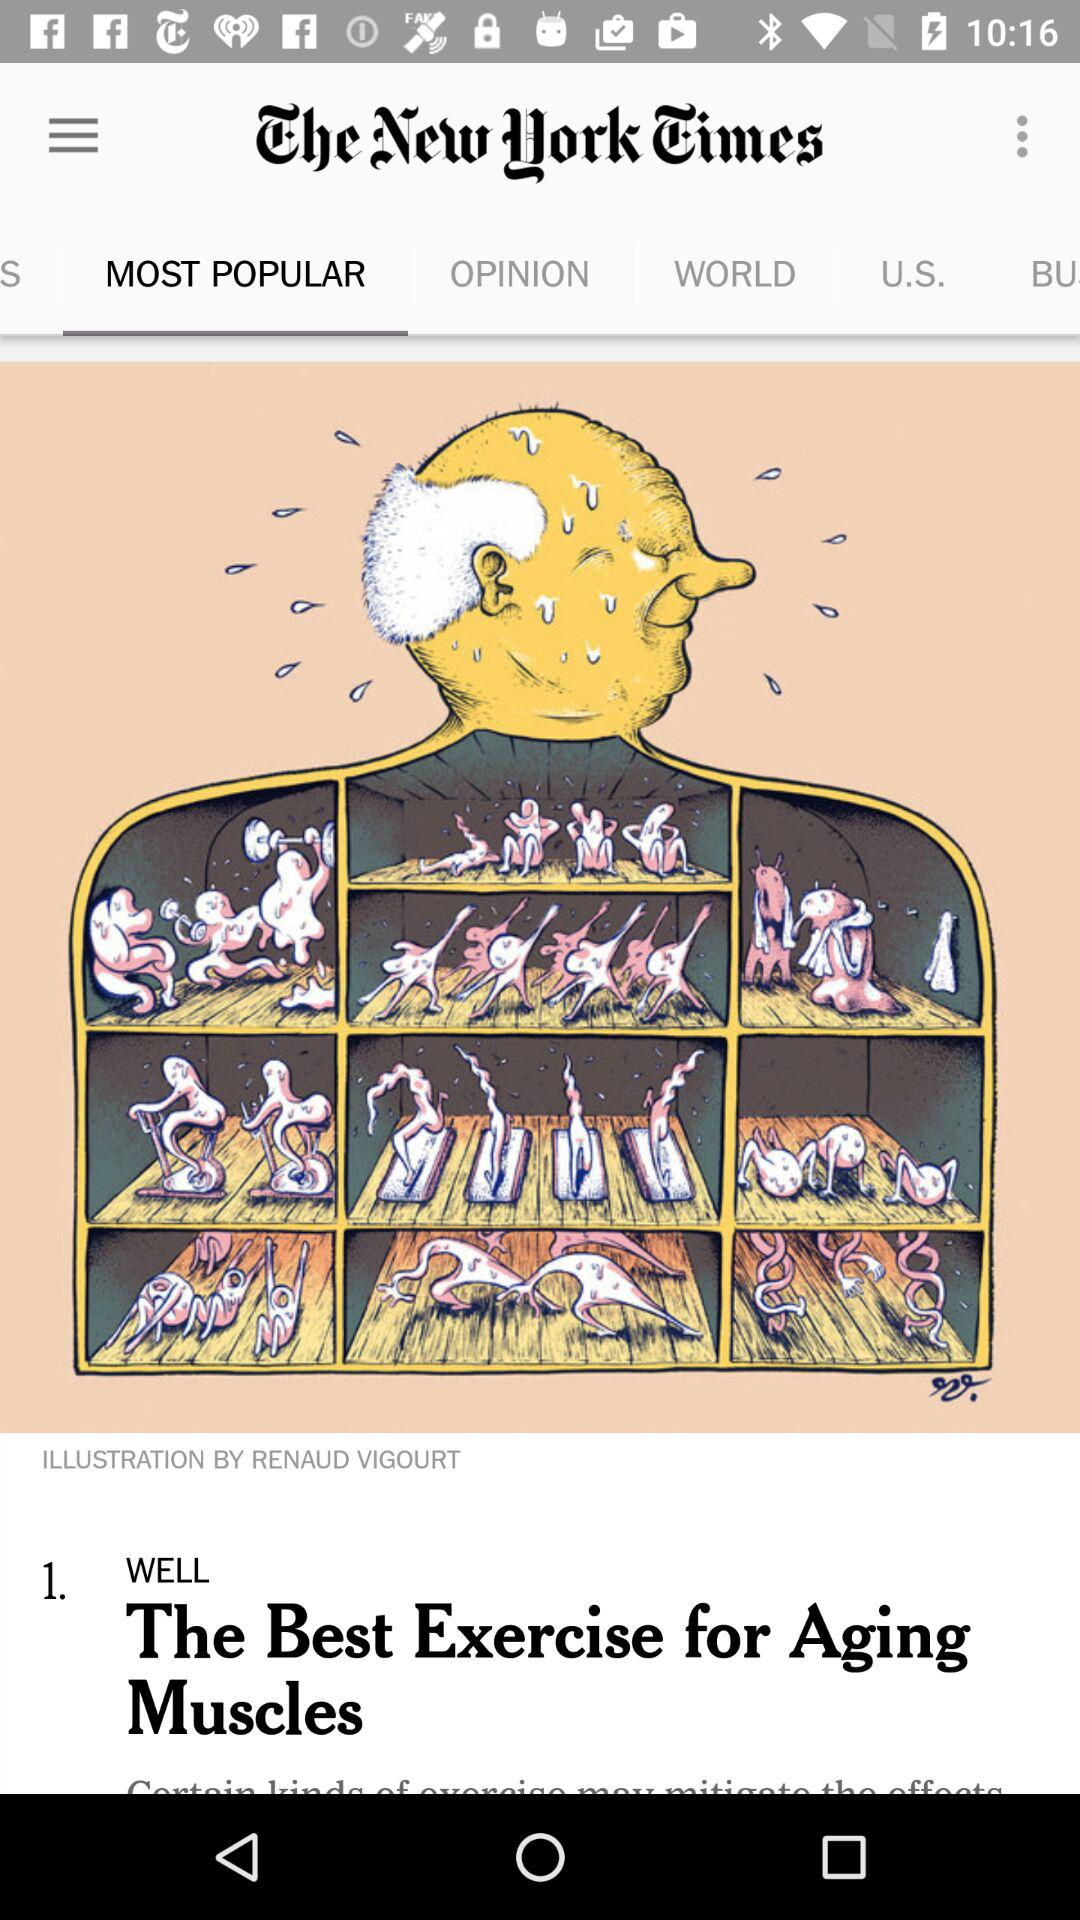What is the newspaper's name? The newspaper's name is "The New York Times". 